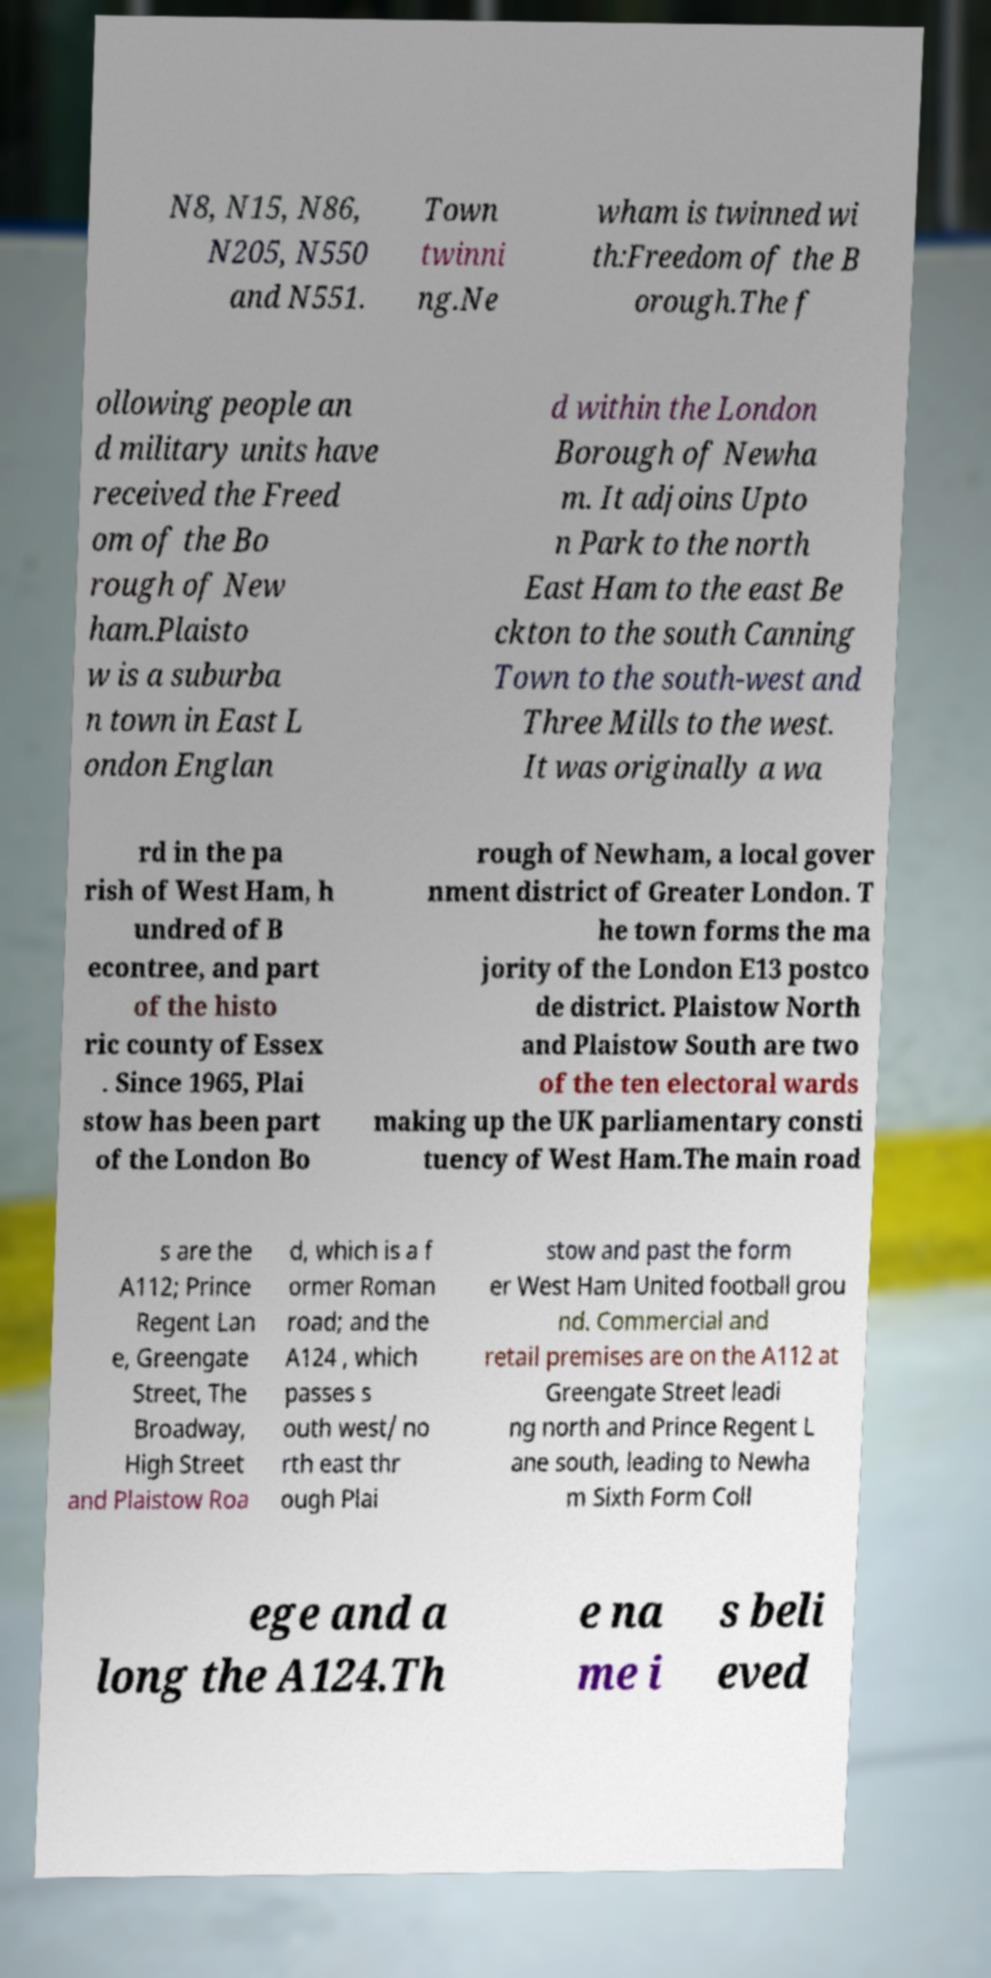Can you accurately transcribe the text from the provided image for me? N8, N15, N86, N205, N550 and N551. Town twinni ng.Ne wham is twinned wi th:Freedom of the B orough.The f ollowing people an d military units have received the Freed om of the Bo rough of New ham.Plaisto w is a suburba n town in East L ondon Englan d within the London Borough of Newha m. It adjoins Upto n Park to the north East Ham to the east Be ckton to the south Canning Town to the south-west and Three Mills to the west. It was originally a wa rd in the pa rish of West Ham, h undred of B econtree, and part of the histo ric county of Essex . Since 1965, Plai stow has been part of the London Bo rough of Newham, a local gover nment district of Greater London. T he town forms the ma jority of the London E13 postco de district. Plaistow North and Plaistow South are two of the ten electoral wards making up the UK parliamentary consti tuency of West Ham.The main road s are the A112; Prince Regent Lan e, Greengate Street, The Broadway, High Street and Plaistow Roa d, which is a f ormer Roman road; and the A124 , which passes s outh west/ no rth east thr ough Plai stow and past the form er West Ham United football grou nd. Commercial and retail premises are on the A112 at Greengate Street leadi ng north and Prince Regent L ane south, leading to Newha m Sixth Form Coll ege and a long the A124.Th e na me i s beli eved 